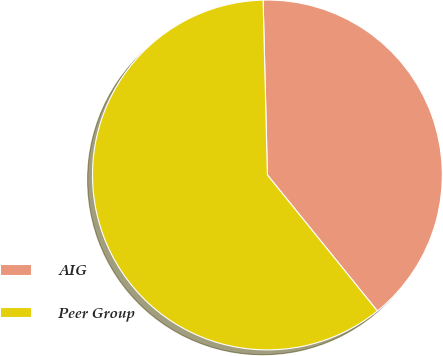Convert chart. <chart><loc_0><loc_0><loc_500><loc_500><pie_chart><fcel>AIG<fcel>Peer Group<nl><fcel>39.57%<fcel>60.43%<nl></chart> 